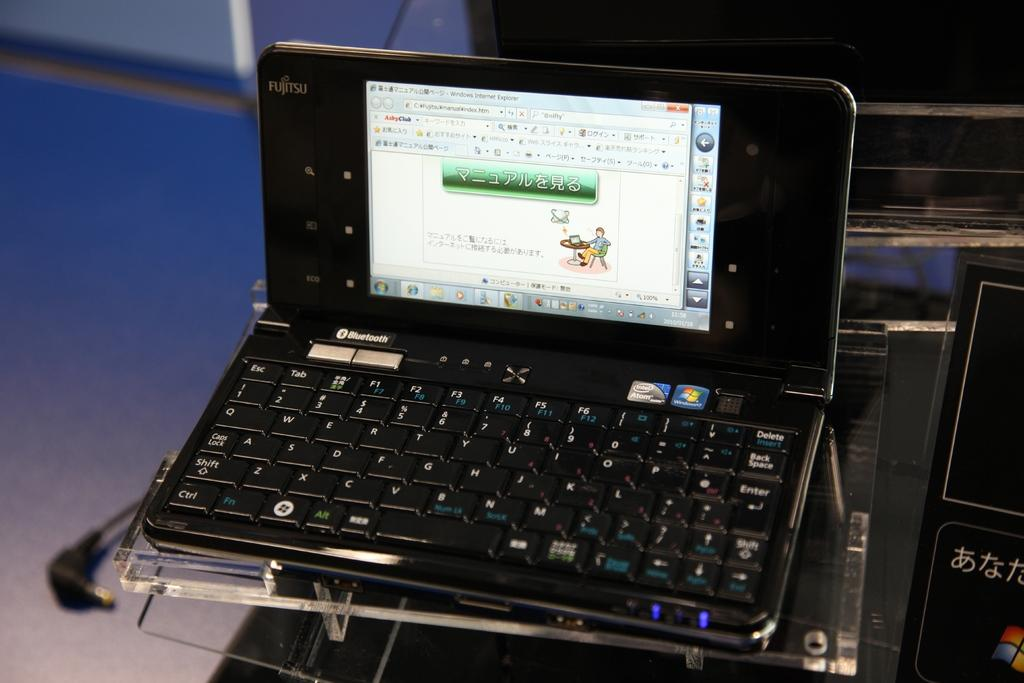Provide a one-sentence caption for the provided image. A laptop powered with an intel atom processor and has bluetooth ability. 